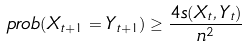<formula> <loc_0><loc_0><loc_500><loc_500>\ p r o b ( X _ { t + 1 } = Y _ { t + 1 } ) \geq \frac { 4 s ( X _ { t } , Y _ { t } ) } { n ^ { 2 } }</formula> 